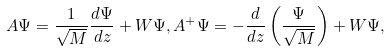Convert formula to latex. <formula><loc_0><loc_0><loc_500><loc_500>A \Psi = \frac { 1 } { \sqrt { M } } \frac { d \Psi } { d z } + W \Psi , A ^ { + } \Psi = - \frac { d } { d z } \left ( \frac { \Psi } { \sqrt { M } } \right ) + W \Psi ,</formula> 